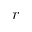Convert formula to latex. <formula><loc_0><loc_0><loc_500><loc_500>r</formula> 